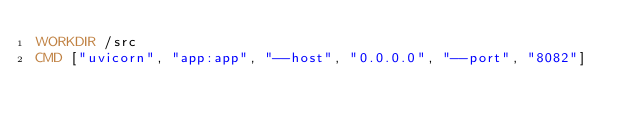Convert code to text. <code><loc_0><loc_0><loc_500><loc_500><_Dockerfile_>WORKDIR /src
CMD ["uvicorn", "app:app", "--host", "0.0.0.0", "--port", "8082"]
</code> 